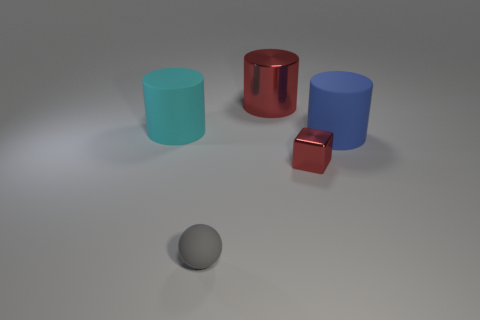Subtract all red metallic cylinders. How many cylinders are left? 2 Add 3 big gray shiny blocks. How many objects exist? 8 Subtract all red cylinders. How many cylinders are left? 2 Subtract 1 cylinders. How many cylinders are left? 2 Add 2 large red objects. How many large red objects are left? 3 Add 1 red metal cylinders. How many red metal cylinders exist? 2 Subtract 0 cyan cubes. How many objects are left? 5 Subtract all cylinders. How many objects are left? 2 Subtract all cyan cubes. Subtract all yellow cylinders. How many cubes are left? 1 Subtract all big green cylinders. Subtract all blue cylinders. How many objects are left? 4 